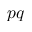Convert formula to latex. <formula><loc_0><loc_0><loc_500><loc_500>p q</formula> 